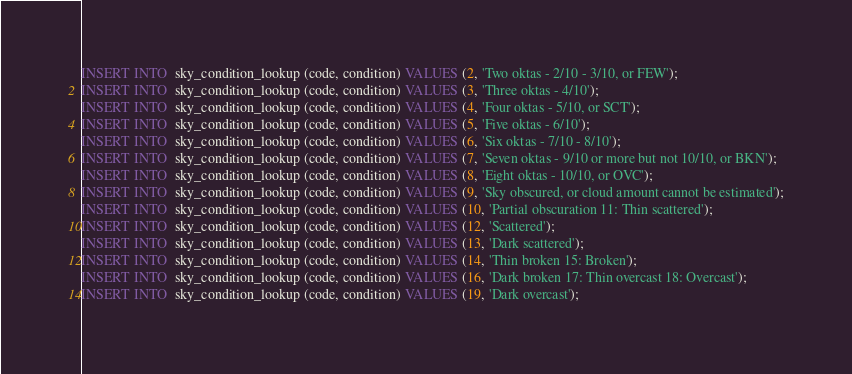<code> <loc_0><loc_0><loc_500><loc_500><_SQL_>INSERT INTO  sky_condition_lookup (code, condition) VALUES (2, 'Two oktas - 2/10 - 3/10, or FEW');
INSERT INTO  sky_condition_lookup (code, condition) VALUES (3, 'Three oktas - 4/10');
INSERT INTO  sky_condition_lookup (code, condition) VALUES (4, 'Four oktas - 5/10, or SCT');
INSERT INTO  sky_condition_lookup (code, condition) VALUES (5, 'Five oktas - 6/10');
INSERT INTO  sky_condition_lookup (code, condition) VALUES (6, 'Six oktas - 7/10 - 8/10');
INSERT INTO  sky_condition_lookup (code, condition) VALUES (7, 'Seven oktas - 9/10 or more but not 10/10, or BKN');
INSERT INTO  sky_condition_lookup (code, condition) VALUES (8, 'Eight oktas - 10/10, or OVC');
INSERT INTO  sky_condition_lookup (code, condition) VALUES (9, 'Sky obscured, or cloud amount cannot be estimated');
INSERT INTO  sky_condition_lookup (code, condition) VALUES (10, 'Partial obscuration 11: Thin scattered');
INSERT INTO  sky_condition_lookup (code, condition) VALUES (12, 'Scattered');
INSERT INTO  sky_condition_lookup (code, condition) VALUES (13, 'Dark scattered');
INSERT INTO  sky_condition_lookup (code, condition) VALUES (14, 'Thin broken 15: Broken');
INSERT INTO  sky_condition_lookup (code, condition) VALUES (16, 'Dark broken 17: Thin overcast 18: Overcast');
INSERT INTO  sky_condition_lookup (code, condition) VALUES (19, 'Dark overcast');</code> 